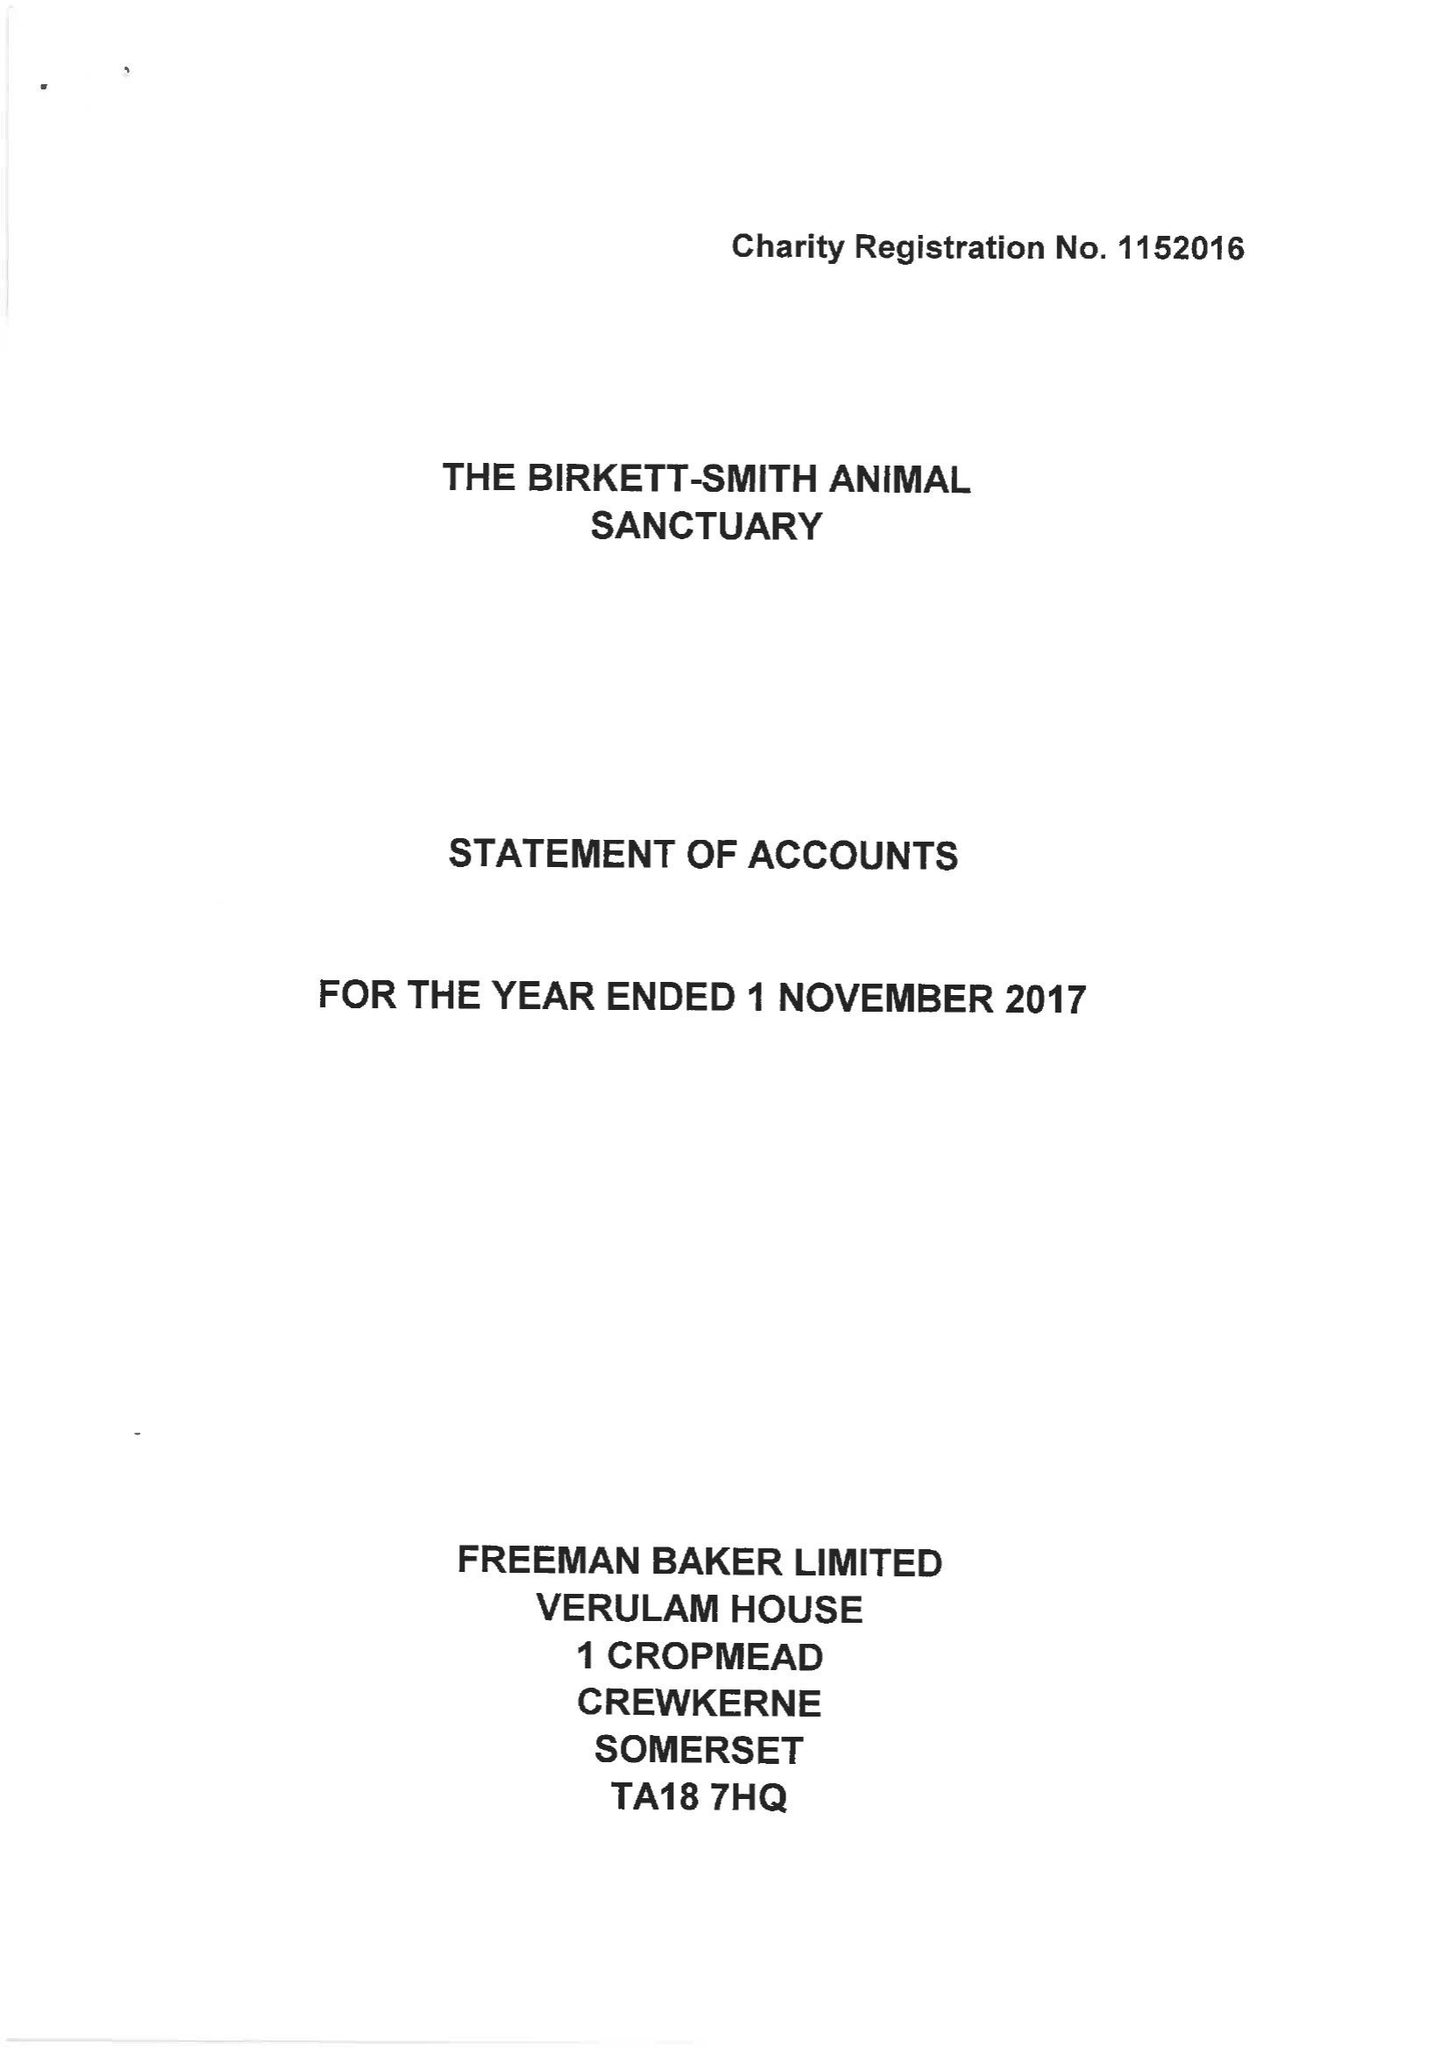What is the value for the address__post_town?
Answer the question using a single word or phrase. BRIDPORT 